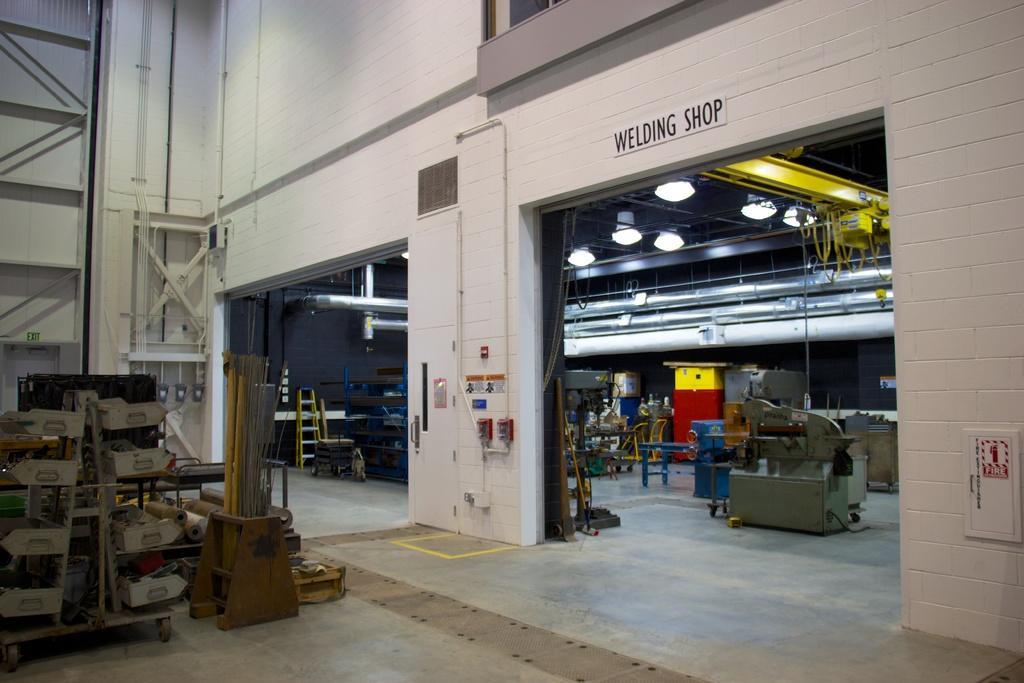What is the tall, vertical object in the image? There is a ladder in the image. What types of equipment can be seen in the image? There are machines in the image. What is used for illumination in the image? There are lights in the image. What surface is present for writing or displaying information? There is a board in the image. What is the general setting or location of the items in the image? The other items in the image are likely in a shed. What type of stove is being used to cook food at the event in the image? There is no stove or event present in the image; it features a ladder, machines, lights, a board, and other items likely in a shed. 